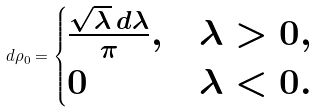Convert formula to latex. <formula><loc_0><loc_0><loc_500><loc_500>d \rho _ { 0 } = \begin{cases} \frac { \sqrt { \lambda } \, d \lambda } { \pi } , & \lambda > 0 , \\ 0 & \lambda < 0 . \end{cases}</formula> 